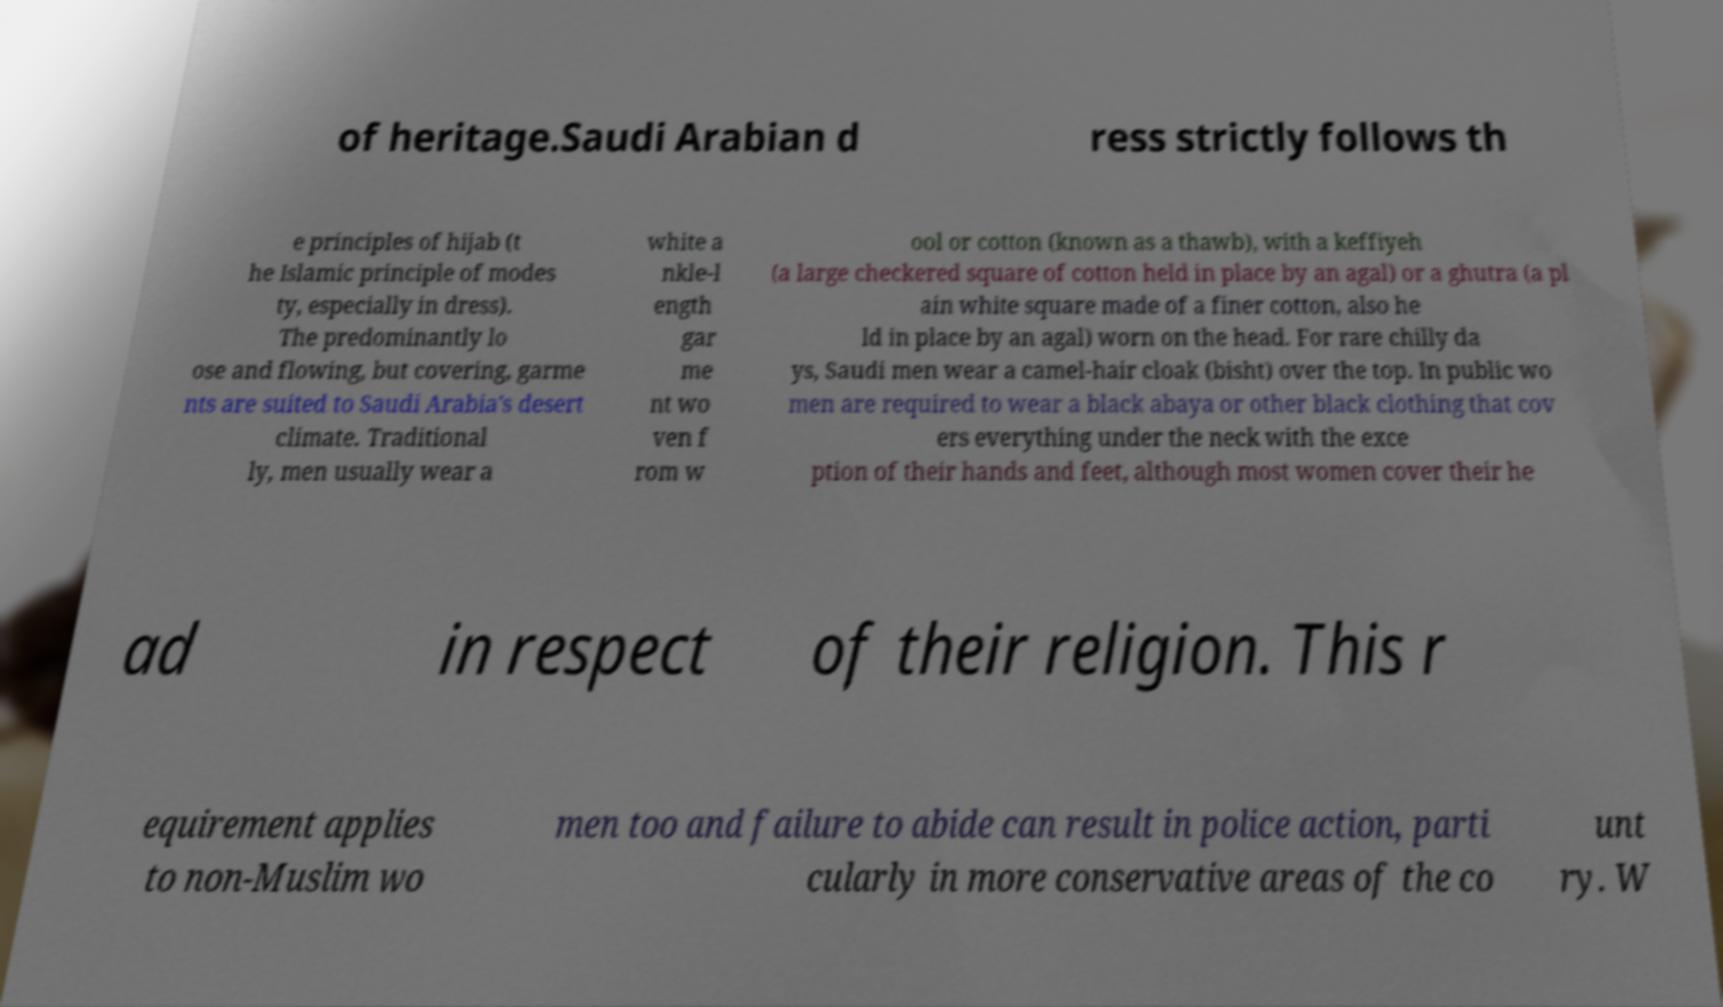Please identify and transcribe the text found in this image. of heritage.Saudi Arabian d ress strictly follows th e principles of hijab (t he Islamic principle of modes ty, especially in dress). The predominantly lo ose and flowing, but covering, garme nts are suited to Saudi Arabia's desert climate. Traditional ly, men usually wear a white a nkle-l ength gar me nt wo ven f rom w ool or cotton (known as a thawb), with a keffiyeh (a large checkered square of cotton held in place by an agal) or a ghutra (a pl ain white square made of a finer cotton, also he ld in place by an agal) worn on the head. For rare chilly da ys, Saudi men wear a camel-hair cloak (bisht) over the top. In public wo men are required to wear a black abaya or other black clothing that cov ers everything under the neck with the exce ption of their hands and feet, although most women cover their he ad in respect of their religion. This r equirement applies to non-Muslim wo men too and failure to abide can result in police action, parti cularly in more conservative areas of the co unt ry. W 